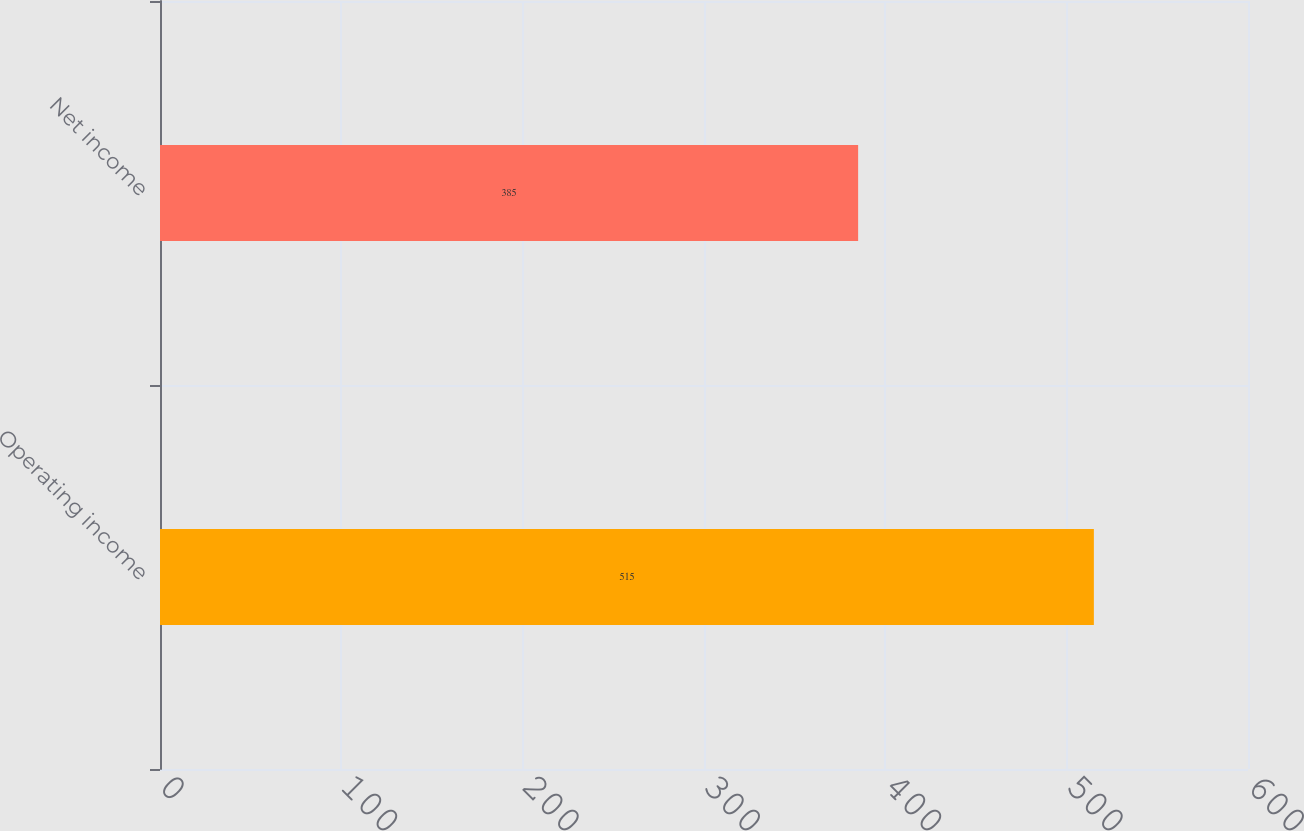Convert chart. <chart><loc_0><loc_0><loc_500><loc_500><bar_chart><fcel>Operating income<fcel>Net income<nl><fcel>515<fcel>385<nl></chart> 